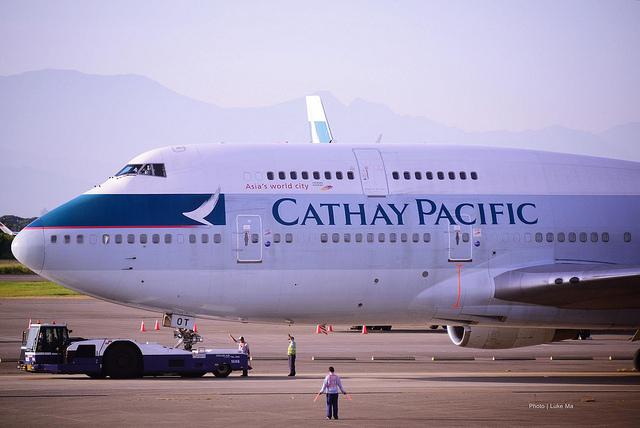What airline is this?
Keep it brief. Cathay pacific. Where are the men pointing?
Give a very brief answer. Airplane. What color is the airplane?
Give a very brief answer. White. 